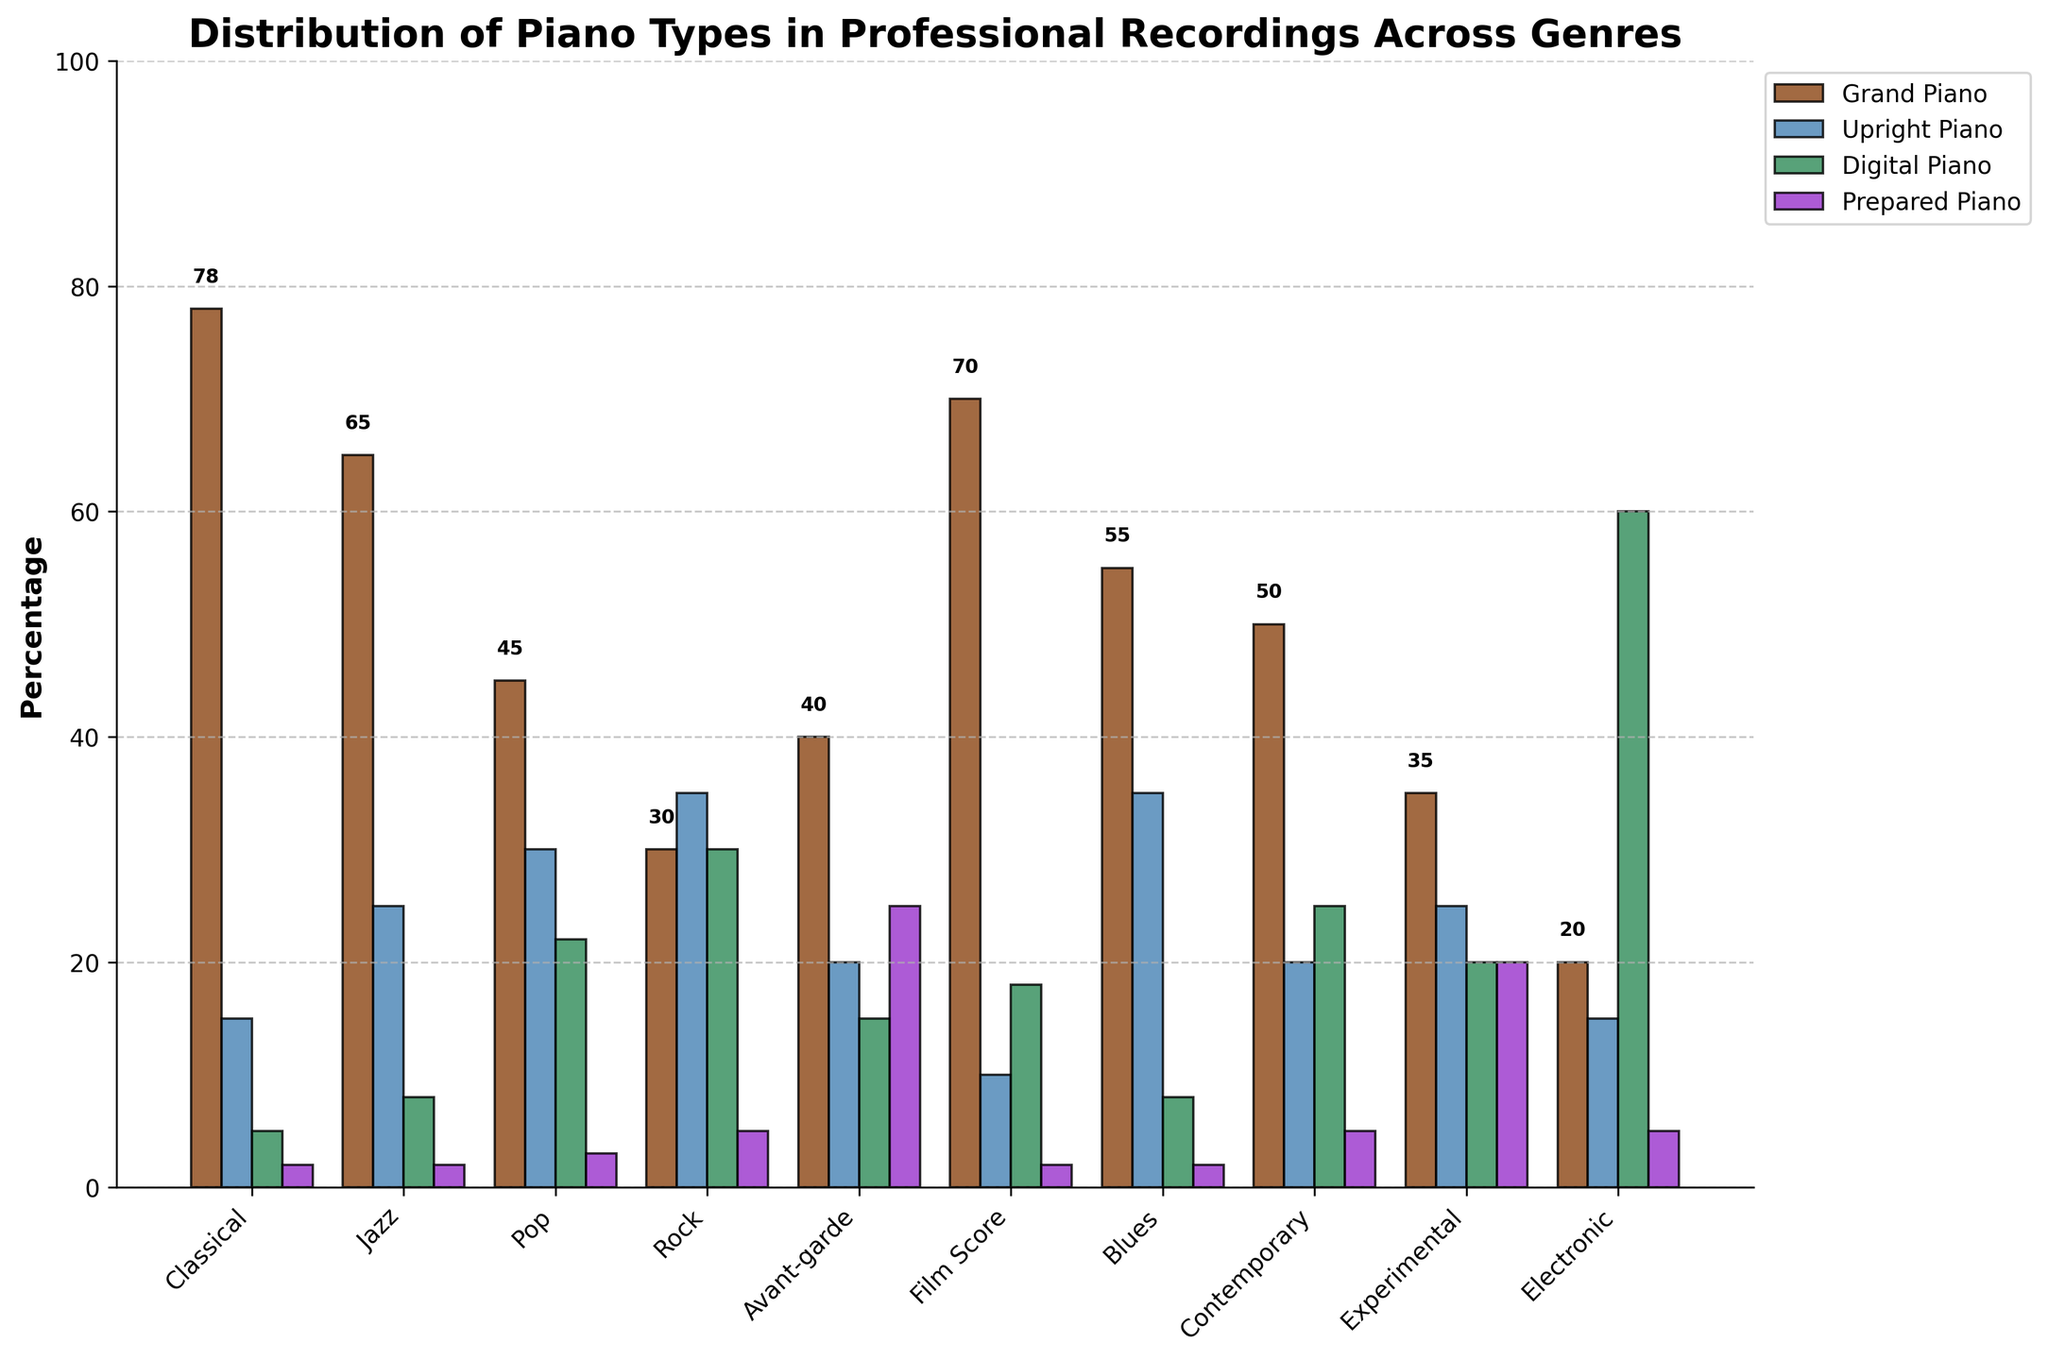Which genre uses Grand Pianos the most? To determine this, look at the different bar heights for Grand Piano across all genres. The tallest bar represents the genre with the highest usage.
Answer: Classical What is the total percentage of Digital Pianos used in all genres combined? Add up the values for Digital Piano across each genre. The values are: 5, 8, 22, 30, 15, 18, 8, 25, 20, 60. Summing these together gives the total percentage.
Answer: 211 Which piano type is used the least in Pop music? Look at the different bar heights for Pop genre. The bar with the shortest height represents the least used piano type.
Answer: Prepared Piano Is the usage of Upright Pianos in Rock higher than in Classical? Compare the heights of the Upright Piano bars in both Rock and Classical genres. The Rock bar is taller.
Answer: Yes How many genres prefer Upright Pianos more than any other type of piano? Examine each genre to see which has the tallest bar for Upright Pianos. Only count the genres if Upright Piano is the tallest bar.
Answer: 0 What is the difference in Prepared Piano usage between Avant-garde and Classical? Compare the heights of the Prepared Piano bars in the Avant-garde and Classical genres. Subtract the smaller value from the larger one, which in this case is 25 (Avant-garde) - 2 (Classical).
Answer: 23 Which genre has the lowest percentage for Digital Piano? Look for the shortest Digital Piano bar across all genres. The shortest bar represents the genre with the lowest percentage.
Answer: Classical In which genres do Prepared Pianos have a percentage of at least 5%? Identify the genres where the Prepared Piano bar reaches or exceeds the height corresponding to 5%. These genres are Pop, Rock, Avant-garde, Contemporary, Experimental, and Electronic.
Answer: Pop, Rock, Avant-garde, Contemporary, Experimental, Electronic Is the percentage of Grand Piano usage in Blues higher or lower than in Jazz? Compare the heights of the Grand Piano bars in Blues and Jazz genres respectively. The bar in Blues is higher.
Answer: Higher What is the average percentage of Grand Piano usage across all genres? Sum the percentage values of Grand Piano usage across all genres and divide by the number of genres. The values are 78, 65, 45, 30, 40, 70, 55, 50, 35, 20. Their sum is 488, which divided by 10 gives the average percentage.
Answer: 48.8 